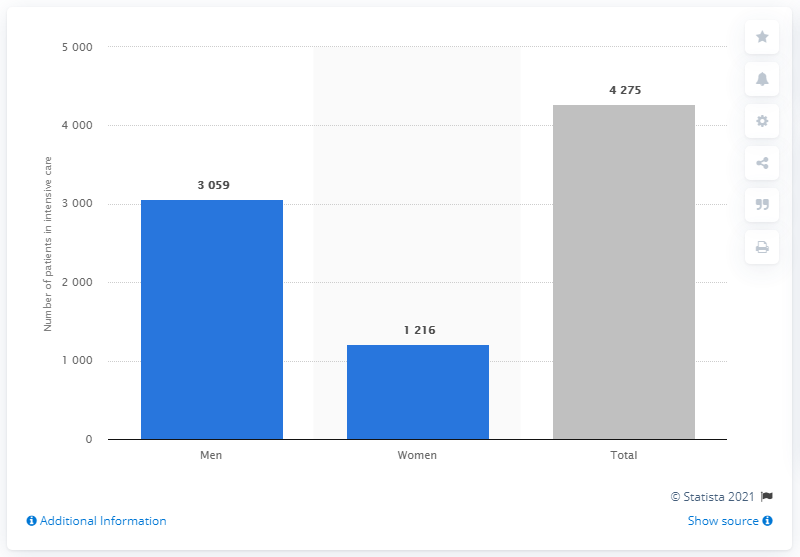What might be the reasons for the disparity in numbers between men and women in this data? There might be multiple factors contributing to the disparity, such as biological differences, gender-based behavioral patterns, occupational exposure risks, or underlying health conditions. However, without more context, it is difficult to pinpoint the exact reasons. 